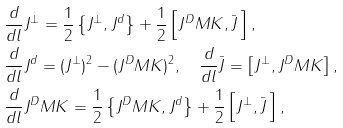<formula> <loc_0><loc_0><loc_500><loc_500>& \frac { d } { d l } J ^ { \perp } = \frac { 1 } { 2 } \left \{ J ^ { \perp } , J ^ { d } \right \} + \frac { 1 } { 2 } \left [ J ^ { D } M K , \bar { J } \, \right ] , \\ & \frac { d } { d l } J ^ { d } = ( J ^ { \perp } ) ^ { 2 } - ( J ^ { D } M K ) ^ { 2 } , \quad \frac { d } { d l } \bar { J } = \left [ J ^ { \perp } , J ^ { D } M K \right ] , \\ & \frac { d } { d l } J ^ { D } M K = \frac { 1 } { 2 } \left \{ J ^ { D } M K , J ^ { d } \right \} + \frac { 1 } { 2 } \left [ J ^ { \perp } , \bar { J } \, \right ] ,</formula> 